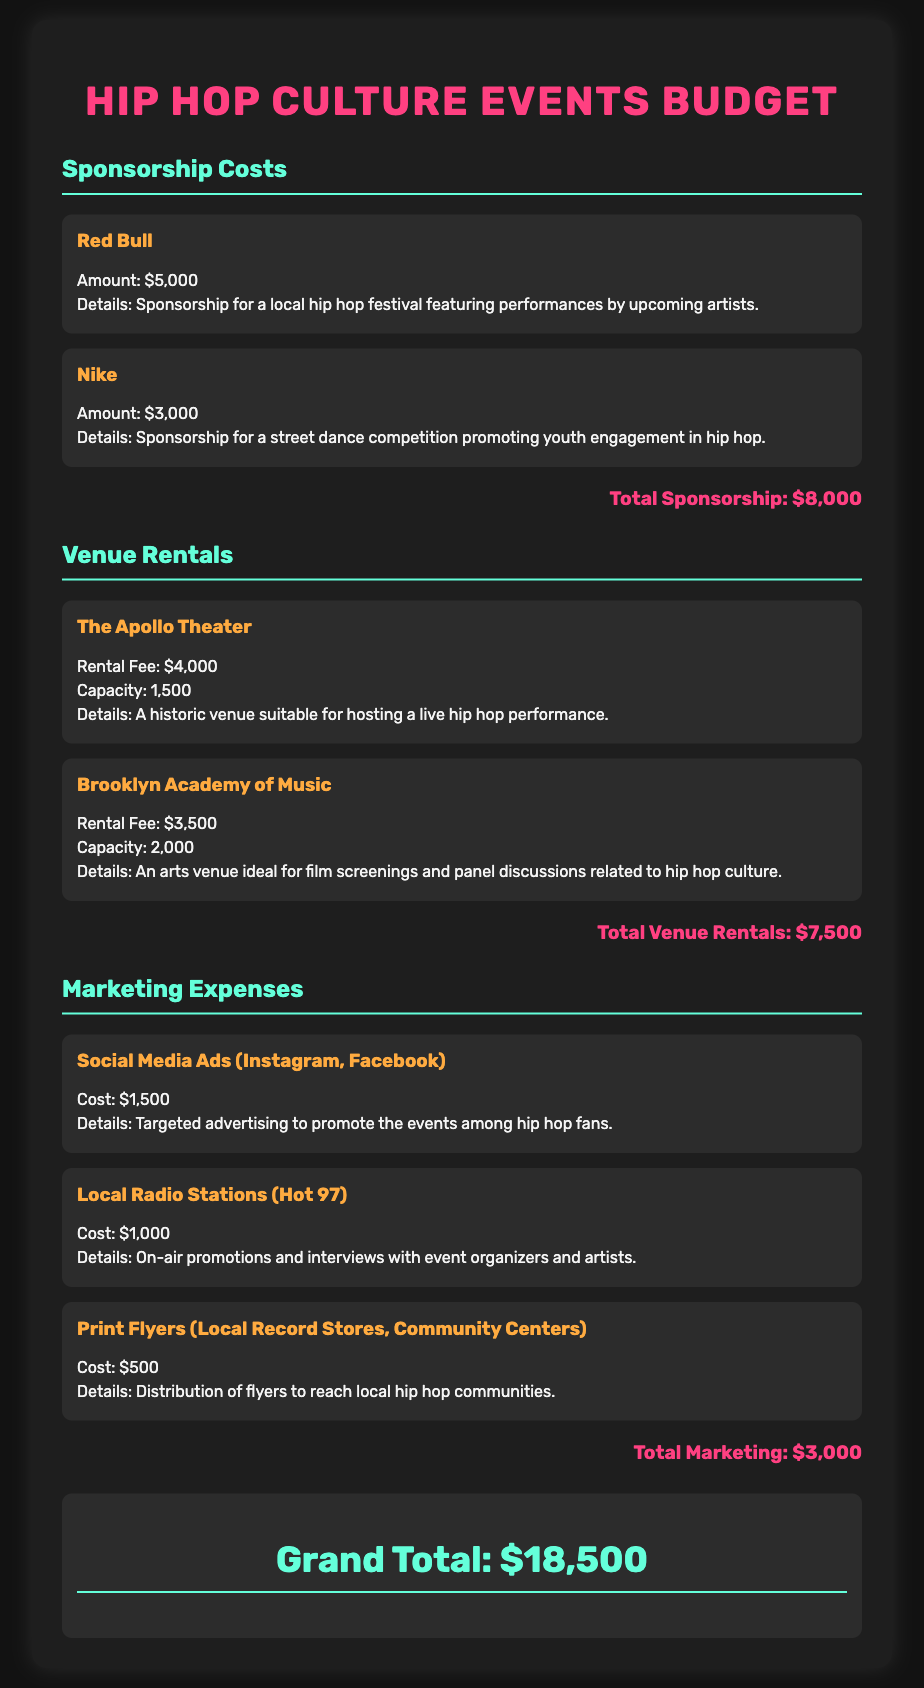What is the total sponsorship cost? The total sponsorship cost is the sum of all sponsorship amounts listed in the document, which is $5,000 + $3,000 = $8,000.
Answer: $8,000 What is the rental fee for The Apollo Theater? The rental fee for The Apollo Theater is stated in the document as $4,000.
Answer: $4,000 How much will be spent on local radio station promotions? The cost allocated for local radio station promotions is specified as $1,000 in the marketing expenses section.
Answer: $1,000 What are the details of the Nike sponsorship? The details provided for the Nike sponsorship include promoting a street dance competition aimed at youth engagement in hip hop for the amount of $3,000.
Answer: Sponsorship for a street dance competition promoting youth engagement in hip hop What is the grand total for the budget? The grand total for the entire budget is indicated at the end of the document, which combines all costs.
Answer: $18,500 